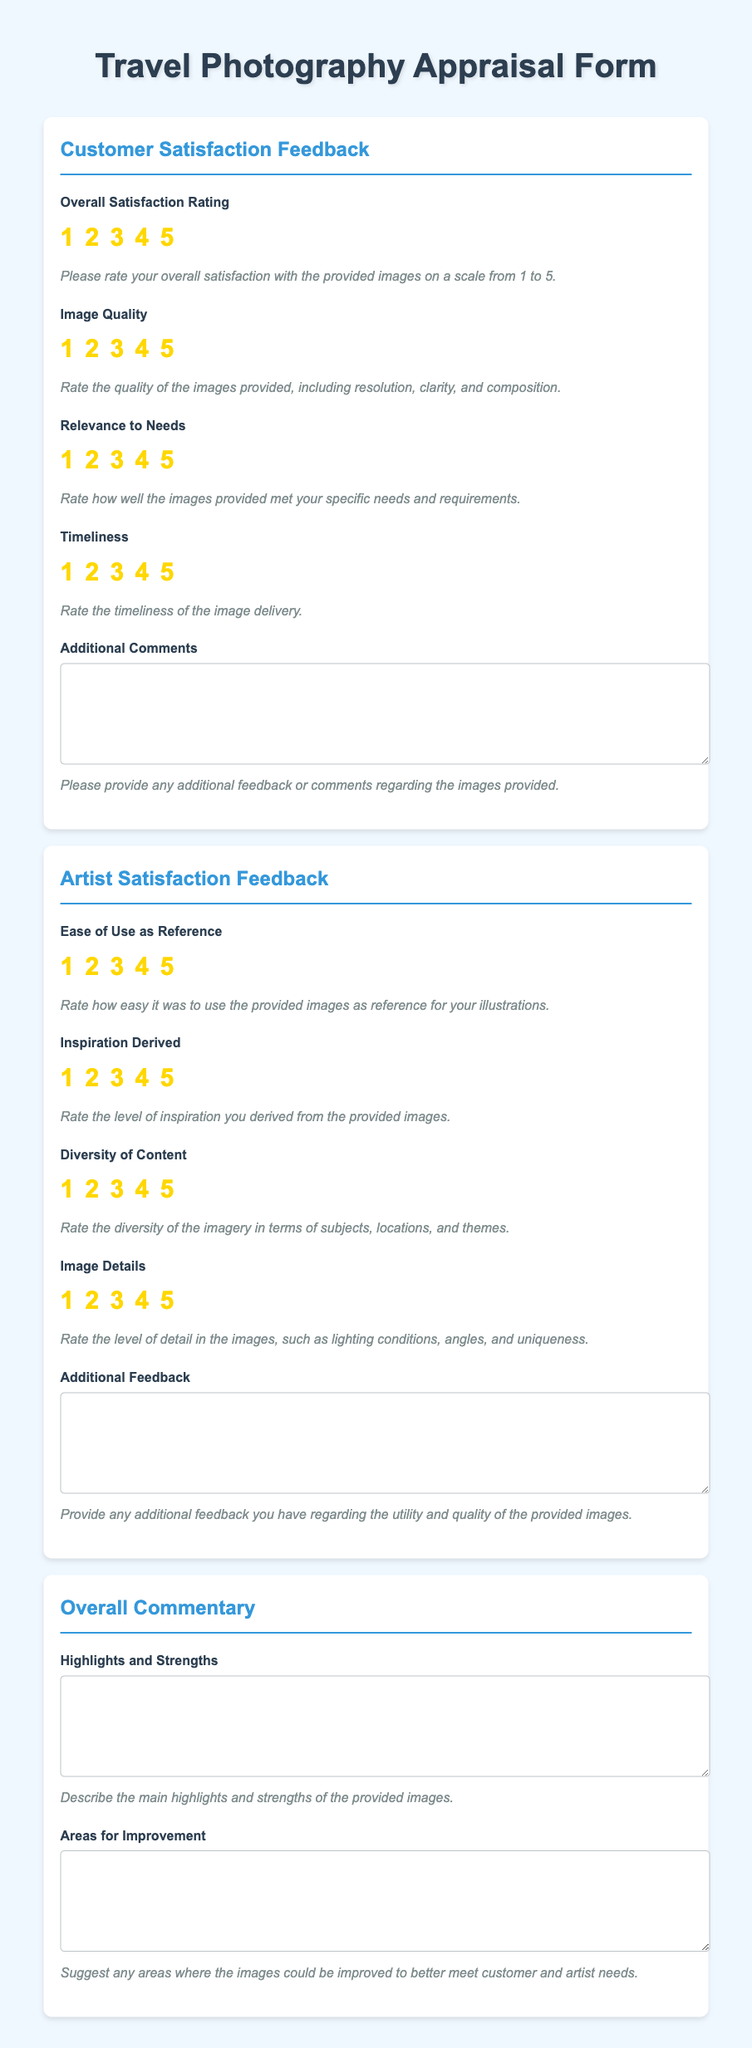what is the title of the document? The title is displayed prominently at the top of the rendered document.
Answer: Travel Photography Appraisal Form how many main sections are there in the document? The document is structured into three main sections which are labeled distinctly.
Answer: 3 what is the highest rating available for image quality? The rating system includes options from 1 to 5 for various fields, with 5 being the highest.
Answer: 5 what feedback can customers provide in the Additional Comments field? This field invites clients to provide further feedback related to the images, which can help in understanding their views better.
Answer: Additional feedback or comments regarding the images provided what is the purpose of the Ease of Use as Reference rating? The rating seeks to understand how accessible the images were for artists to use as references for their work.
Answer: To evaluate how easy it was for artists to use the images as references what kind of comments are artists asked to provide in the Additional Feedback section? Artists are encouraged to share their thoughts on the utility and quality of the images specifically used for their work.
Answer: Feedback regarding the utility and quality of the provided images what does the Timeliness field assess? This field evaluates how promptly the images were delivered to the customers.
Answer: The timeliness of the image delivery what aspect of the images does the Diversity of Content field analyze? This field focuses on evaluating the range of subjects, locations, and themes presented in the provided images.
Answer: Diversity of imagery in terms of subjects, locations, and themes 